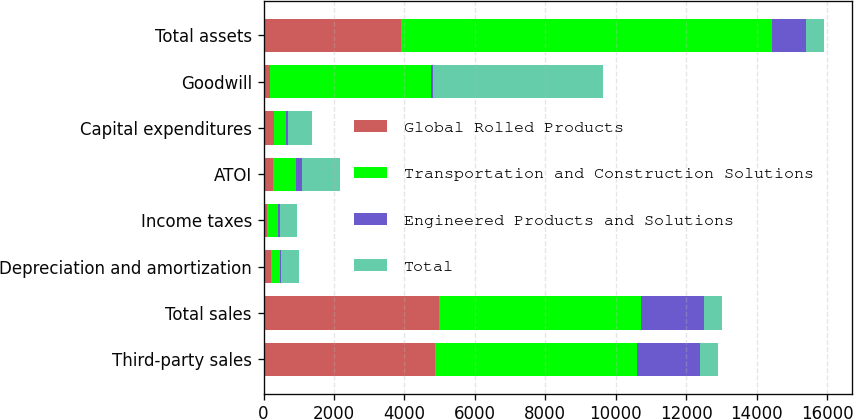<chart> <loc_0><loc_0><loc_500><loc_500><stacked_bar_chart><ecel><fcel>Third-party sales<fcel>Total sales<fcel>Depreciation and amortization<fcel>Income taxes<fcel>ATOI<fcel>Capital expenditures<fcel>Goodwill<fcel>Total assets<nl><fcel>Global Rolled Products<fcel>4864<fcel>4982<fcel>201<fcel>107<fcel>269<fcel>293<fcel>181<fcel>3891<nl><fcel>Transportation and Construction Solutions<fcel>5728<fcel>5728<fcel>255<fcel>298<fcel>642<fcel>333<fcel>4579<fcel>10542<nl><fcel>Engineered Products and Solutions<fcel>1802<fcel>1802<fcel>48<fcel>67<fcel>176<fcel>63<fcel>57<fcel>982<nl><fcel>Total<fcel>504<fcel>504<fcel>504<fcel>472<fcel>1087<fcel>689<fcel>4817<fcel>504<nl></chart> 